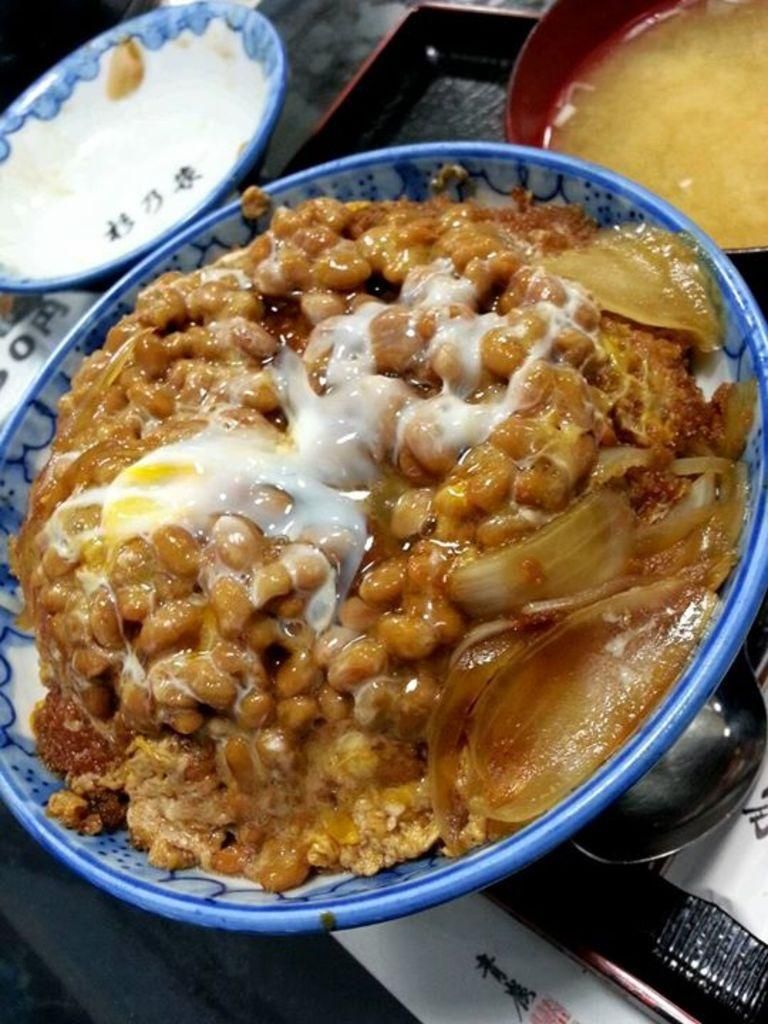What is in the bowl that is visible in the image? There is a bowl filled with food items in the image. What utensil is visible in the image? There is a spoon visible in the image. How many bowls can be seen in the image? There are other bowls in the image. What type of bridge can be seen in the background of the image? There is no bridge present in the image; it only features bowls and a spoon. 